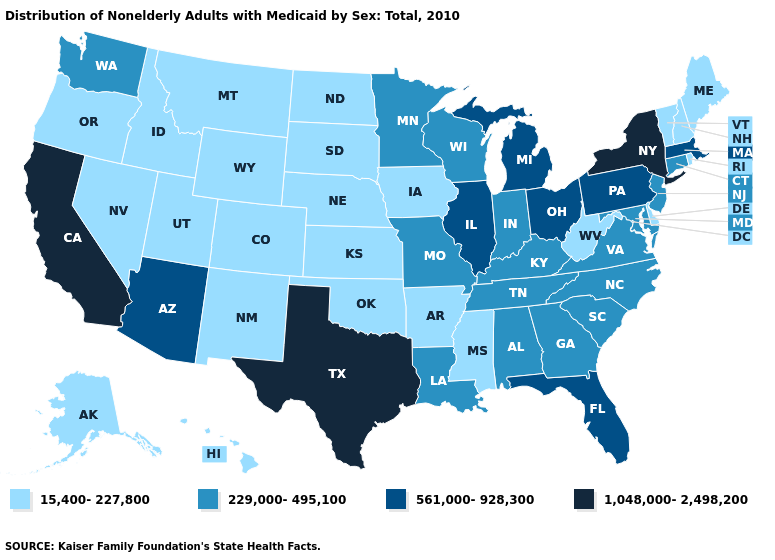Does Vermont have the same value as Delaware?
Concise answer only. Yes. Among the states that border Colorado , does Arizona have the lowest value?
Concise answer only. No. Does New York have the lowest value in the Northeast?
Concise answer only. No. Name the states that have a value in the range 229,000-495,100?
Keep it brief. Alabama, Connecticut, Georgia, Indiana, Kentucky, Louisiana, Maryland, Minnesota, Missouri, New Jersey, North Carolina, South Carolina, Tennessee, Virginia, Washington, Wisconsin. Is the legend a continuous bar?
Quick response, please. No. Among the states that border Wisconsin , does Illinois have the highest value?
Short answer required. Yes. Name the states that have a value in the range 1,048,000-2,498,200?
Keep it brief. California, New York, Texas. Which states have the lowest value in the West?
Short answer required. Alaska, Colorado, Hawaii, Idaho, Montana, Nevada, New Mexico, Oregon, Utah, Wyoming. Which states have the lowest value in the USA?
Quick response, please. Alaska, Arkansas, Colorado, Delaware, Hawaii, Idaho, Iowa, Kansas, Maine, Mississippi, Montana, Nebraska, Nevada, New Hampshire, New Mexico, North Dakota, Oklahoma, Oregon, Rhode Island, South Dakota, Utah, Vermont, West Virginia, Wyoming. What is the value of Texas?
Short answer required. 1,048,000-2,498,200. Among the states that border Arkansas , which have the lowest value?
Be succinct. Mississippi, Oklahoma. What is the highest value in the West ?
Answer briefly. 1,048,000-2,498,200. What is the lowest value in the USA?
Keep it brief. 15,400-227,800. Does Oklahoma have the lowest value in the South?
Quick response, please. Yes. What is the lowest value in states that border Kentucky?
Quick response, please. 15,400-227,800. 